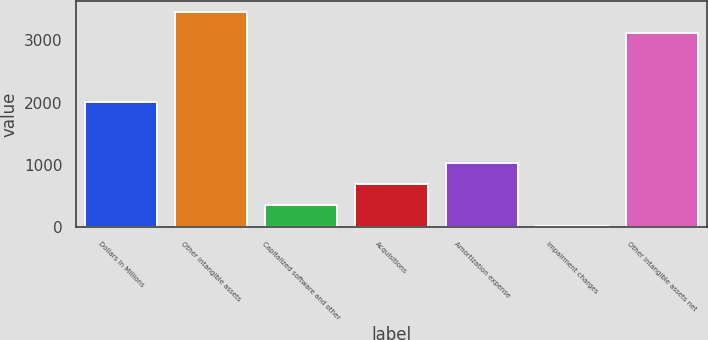<chart> <loc_0><loc_0><loc_500><loc_500><bar_chart><fcel>Dollars in Millions<fcel>Other intangible assets<fcel>Capitalized software and other<fcel>Acquisitions<fcel>Amortization expense<fcel>Impairment charges<fcel>Other intangible assets net<nl><fcel>2011<fcel>3458<fcel>364<fcel>698<fcel>1032<fcel>30<fcel>3124<nl></chart> 